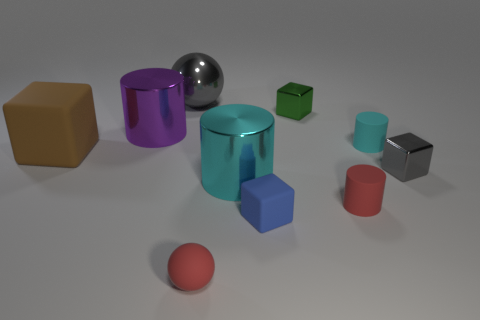Is the shape of the cyan thing in front of the tiny gray metallic thing the same as  the cyan rubber object?
Ensure brevity in your answer.  Yes. What number of objects are either objects that are in front of the small blue object or purple cubes?
Your answer should be very brief. 1. What is the color of the other large metal object that is the same shape as the large purple shiny thing?
Your answer should be very brief. Cyan. Are there any other things of the same color as the large ball?
Make the answer very short. Yes. How big is the red matte thing that is on the left side of the green shiny block?
Make the answer very short. Small. Is the color of the big shiny ball the same as the tiny shiny object in front of the big purple cylinder?
Give a very brief answer. Yes. What number of other things are the same material as the tiny gray cube?
Your answer should be compact. 4. Is the number of cyan rubber cylinders greater than the number of tiny red matte things?
Your response must be concise. No. There is a ball that is in front of the tiny blue thing; is its color the same as the large metal ball?
Ensure brevity in your answer.  No. The tiny rubber cube has what color?
Keep it short and to the point. Blue. 